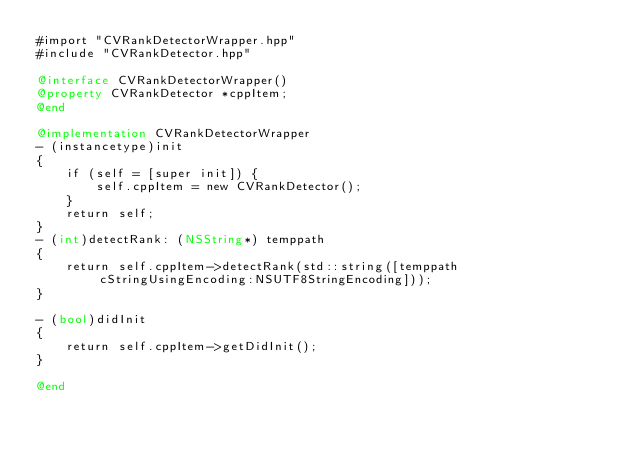<code> <loc_0><loc_0><loc_500><loc_500><_ObjectiveC_>#import "CVRankDetectorWrapper.hpp"
#include "CVRankDetector.hpp"

@interface CVRankDetectorWrapper()
@property CVRankDetector *cppItem;
@end

@implementation CVRankDetectorWrapper
- (instancetype)init
{
    if (self = [super init]) {
        self.cppItem = new CVRankDetector();
    }
    return self;
}
- (int)detectRank: (NSString*) temppath
{
    return self.cppItem->detectRank(std::string([temppath cStringUsingEncoding:NSUTF8StringEncoding]));
}

- (bool)didInit
{
    return self.cppItem->getDidInit();
}

@end</code> 